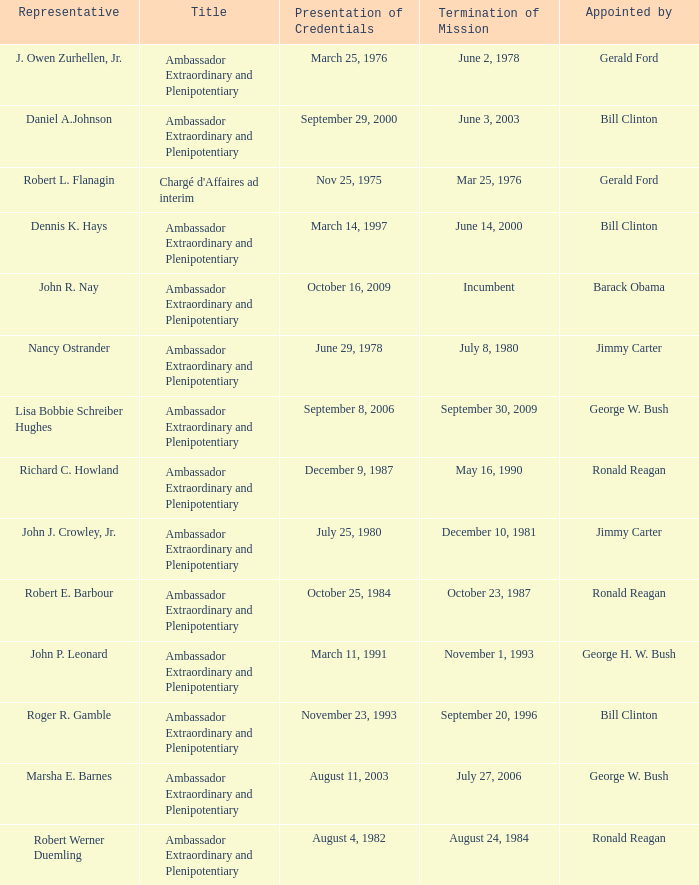What is the Termination of Mission date for Marsha E. Barnes, the Ambassador Extraordinary and Plenipotentiary? July 27, 2006. 